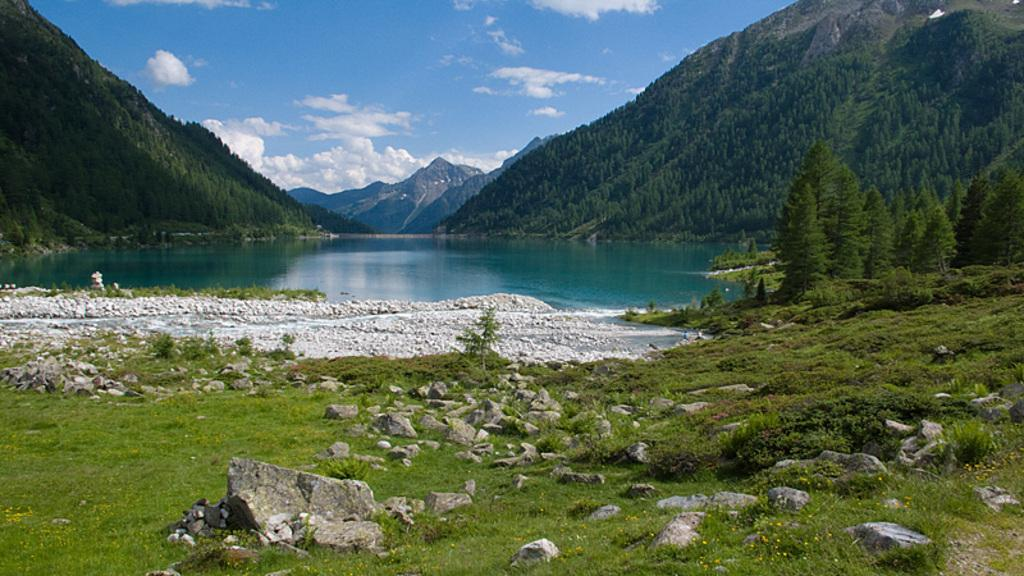What type of natural features can be seen in the image? There are trees, hills, and water visible in the image. What is located at the bottom of the image? There are rocks and water at the bottom of the image. What can be seen in the sky at the top of the image? There are clouds in the sky at the top of the image. What scent is associated with the crayon in the image? There is no crayon present in the image, so there is no scent associated with it. 